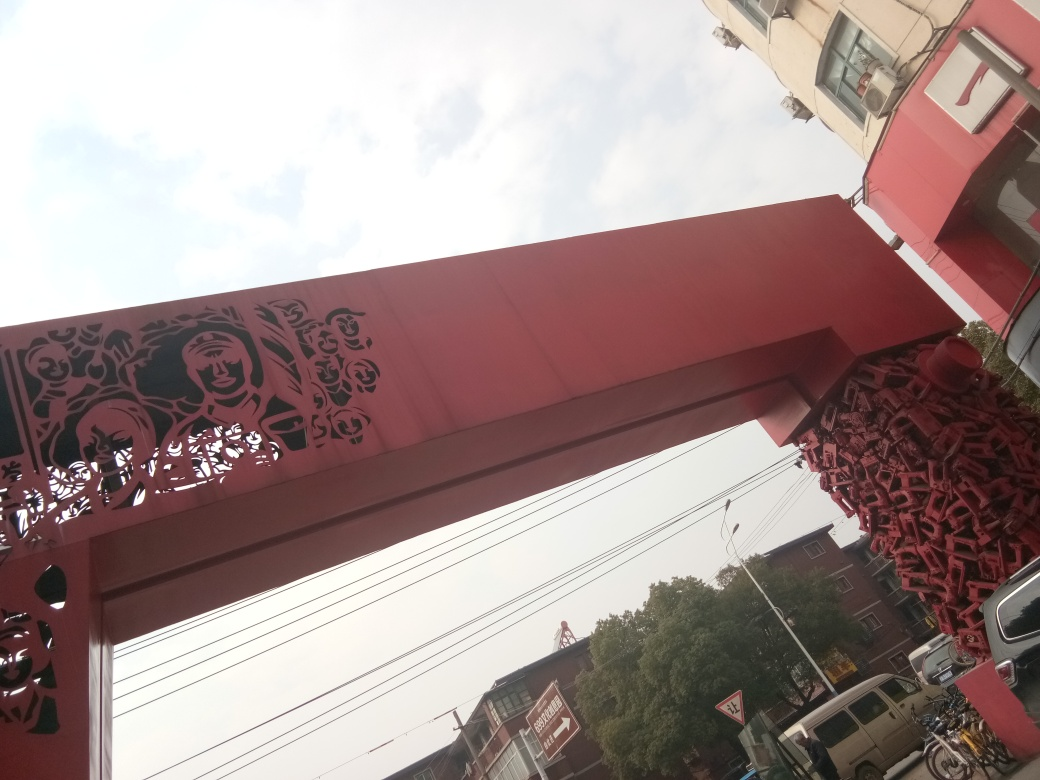Are there any quality issues with this image? Yes, there are several quality issues with this image. First, the image is tilted to the left, which gives an unbalanced view and can be disorienting. Second, the photo is overexposed in the sky area, leading to a lack of detail in the clouds. Third, there appears to be motion blur, possibly due to the camera being moved during the shot or a slow shutter speed. Lastly, the composition could be improved for a more aesthetically pleasing capture, as the current framing cuts off some elements, like the top of the structure and the objects at the bottom. 